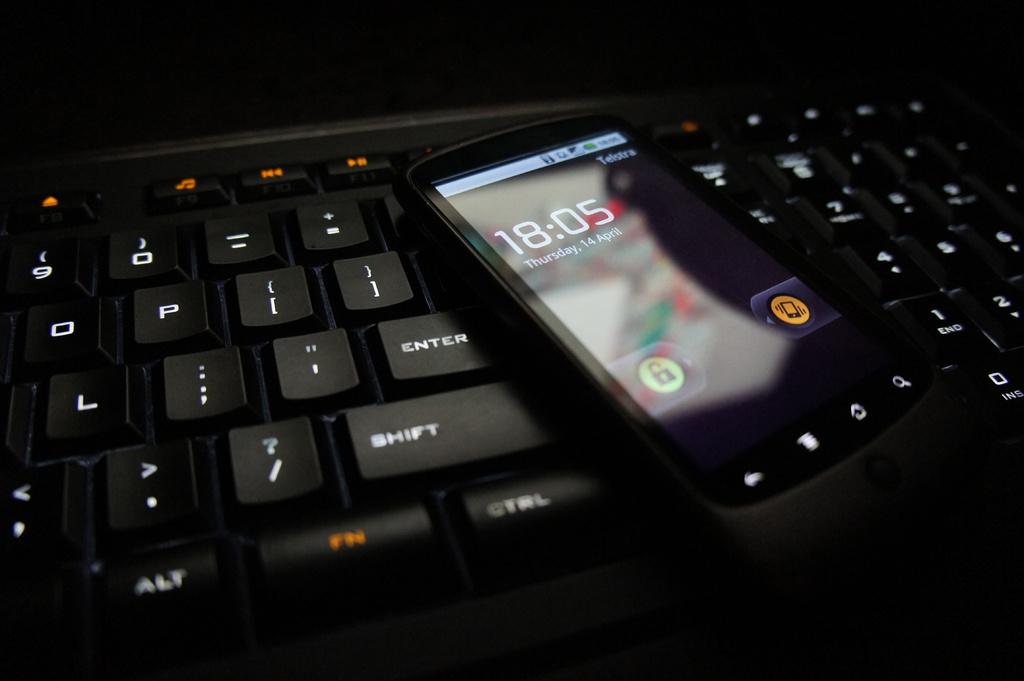What time is on the phone?
Ensure brevity in your answer.  18:05. 